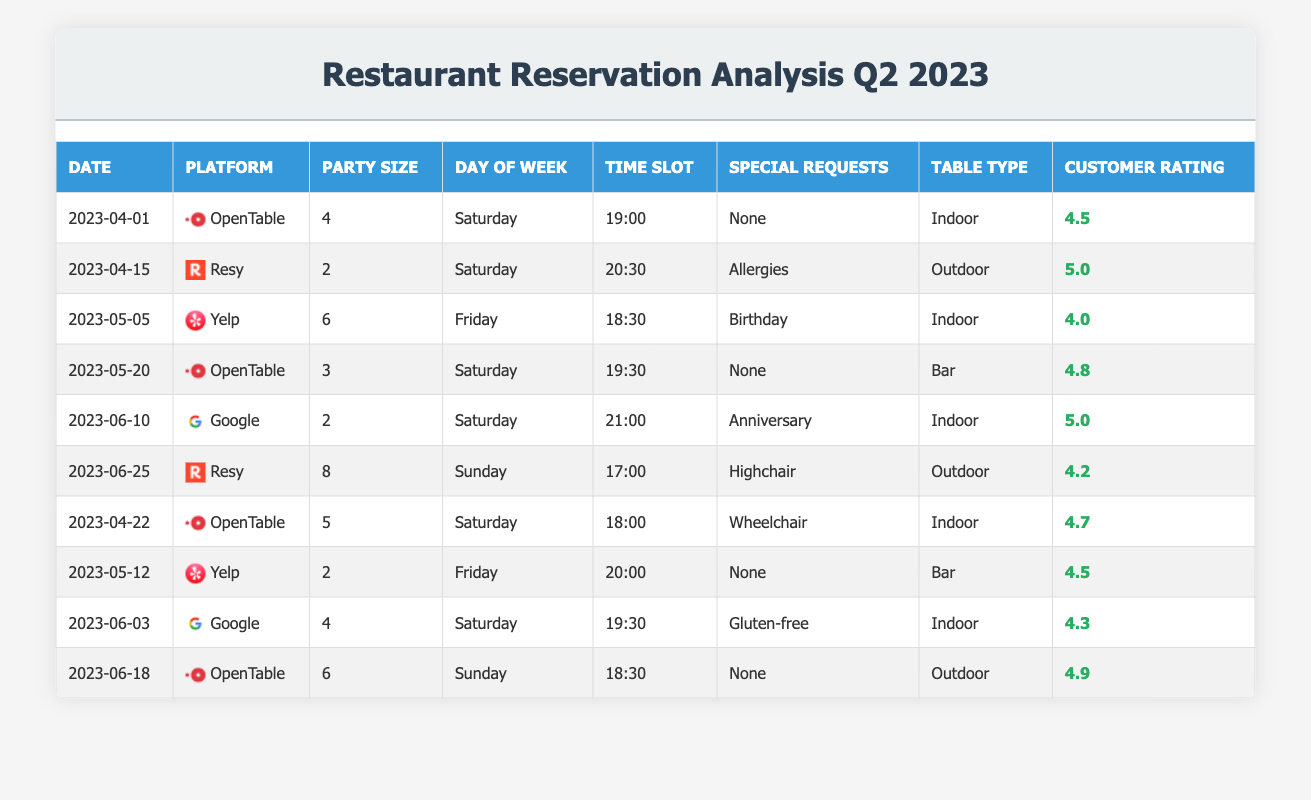What is the highest customer rating recorded in the reservations? The highest customer rating in the table is 5.0. This can be found by scanning the Customer Rating column and identifying the maximum value among all entries.
Answer: 5.0 Which platform had reservations on the most days during Q2 2023? By checking the dates for each platform in the table, we see that OpenTable has reservations on four different days (April 1, April 22, May 20, June 18), while Resy and Google have reservations on two different days each, and Yelp has reservations on two different days as well.
Answer: OpenTable What is the average party size for all reservations in the table? To calculate the average party size, we sum all party sizes (4 + 2 + 6 + 3 + 2 + 8 + 5 + 2 + 4 + 6) = 42. There are 10 reservations, so we divide 42 by 10, which equals 4.2.
Answer: 4.2 Did any reservation request a special accommodation for allergies? Yes, there is a reservation on April 15 that includes a special request for allergies as noted in the Special Requests column.
Answer: Yes What was the average customer rating for reservations at indoor tables? To find the average customer rating for indoor tables, we first identify all the ratings for indoor table types: 4.5 (April 1), 4.0 (May 5), 4.8 (May 20), 5.0 (June 10), 4.3 (June 3). The sum of these ratings is 4.5 + 4.0 + 4.8 + 5.0 + 4.3 = 22.6. There are 5 ratings, so dividing by 5 gives us an average of 4.52.
Answer: 4.52 Which day of the week had the highest average customer rating? To determine the day with the highest average customer rating, calculate the average rating for each day of the week: Saturday has ratings of 4.5, 5.0, 4.0, 4.8, 4.3 (average = 4.52), and Sunday has ratings of 4.2 and 4.9 (average = 4.55). Since Sunday has a higher average, it is the best day.
Answer: Sunday 